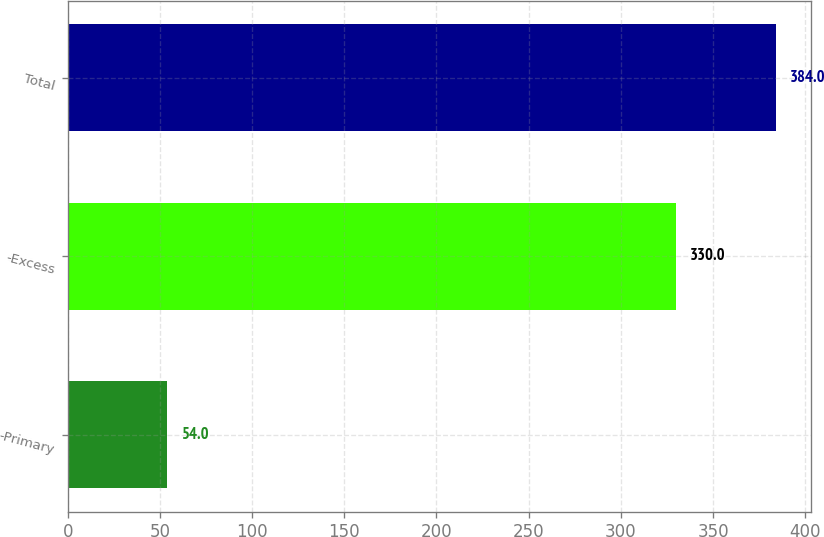<chart> <loc_0><loc_0><loc_500><loc_500><bar_chart><fcel>-Primary<fcel>-Excess<fcel>Total<nl><fcel>54<fcel>330<fcel>384<nl></chart> 